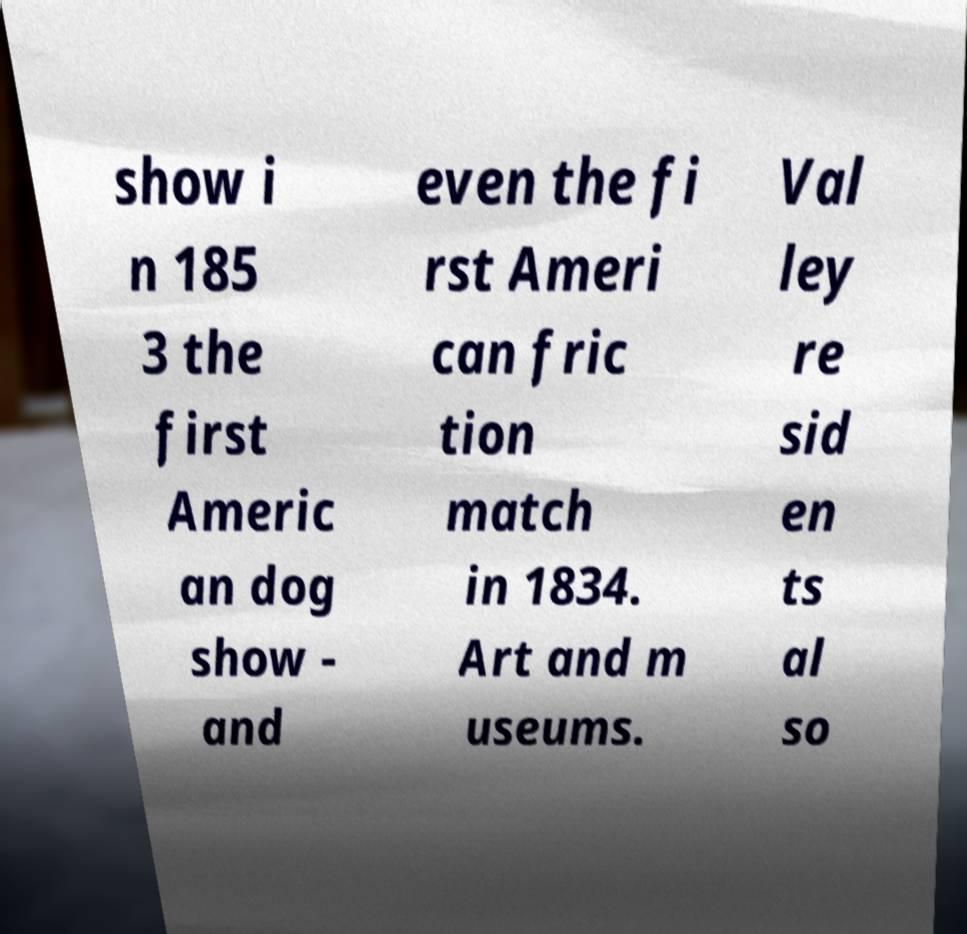For documentation purposes, I need the text within this image transcribed. Could you provide that? show i n 185 3 the first Americ an dog show - and even the fi rst Ameri can fric tion match in 1834. Art and m useums. Val ley re sid en ts al so 